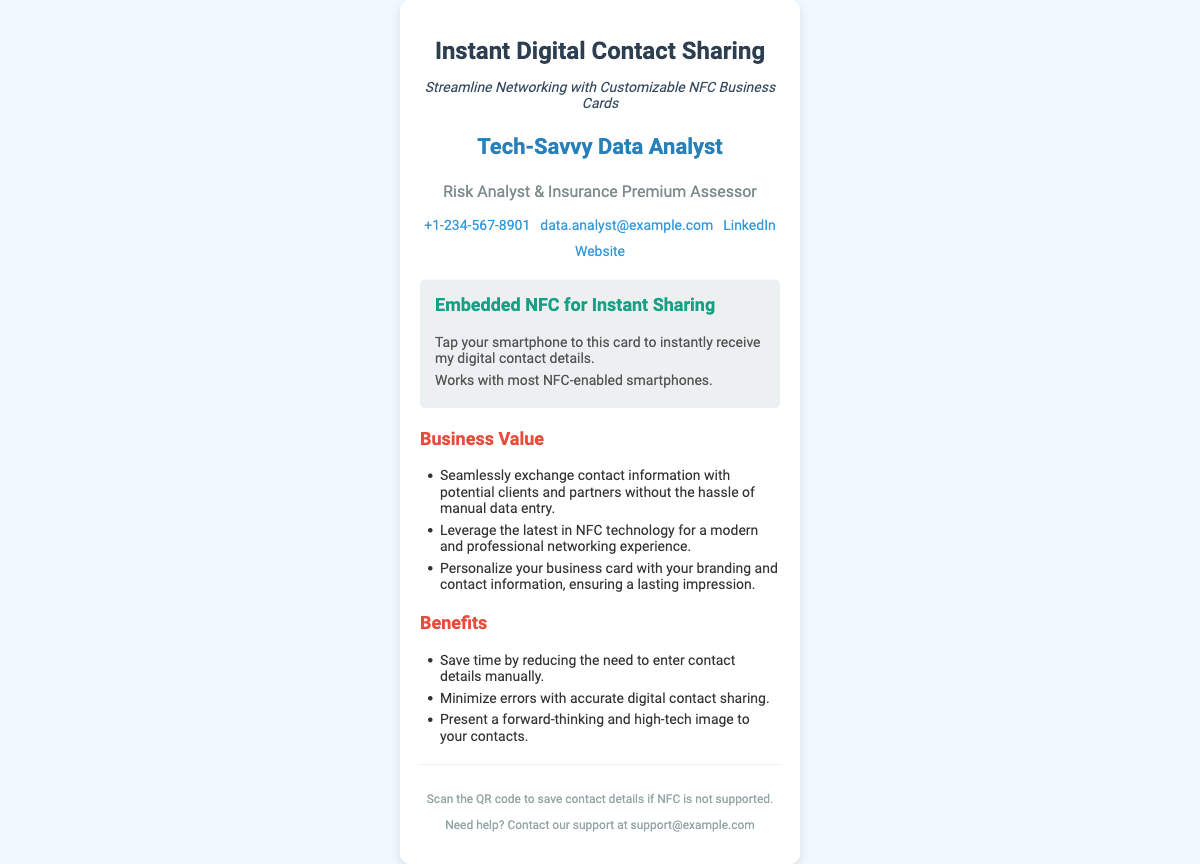What is the name on the business card? The name listed on the business card is found in the personal info section.
Answer: Tech-Savvy Data Analyst What is the title of the individual? The title is provided under the personal information section of the card.
Answer: Risk Analyst & Insurance Premium Assessor What is the contact phone number? The phone number is present in the contact information area of the card.
Answer: +1-234-567-8901 What is the primary feature of this business card? The feature is outlined in the NFC tag section of the card.
Answer: Embedded NFC for Instant Sharing How does the NFC technology benefit networking? The benefits are listed in the business value section of the card.
Answer: Save time by reducing manual entry What should you do if NFC is not supported? This information is provided in the footer of the card.
Answer: Scan the QR code What technology does this business card use? The type of technology employed is mentioned in the NFC tag section.
Answer: NFC technology What should you do to save contact details according to the card? The action to take when NFC is unsupported is indicated in the footer.
Answer: Scan the QR code 